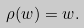<formula> <loc_0><loc_0><loc_500><loc_500>\rho ( w ) = w .</formula> 